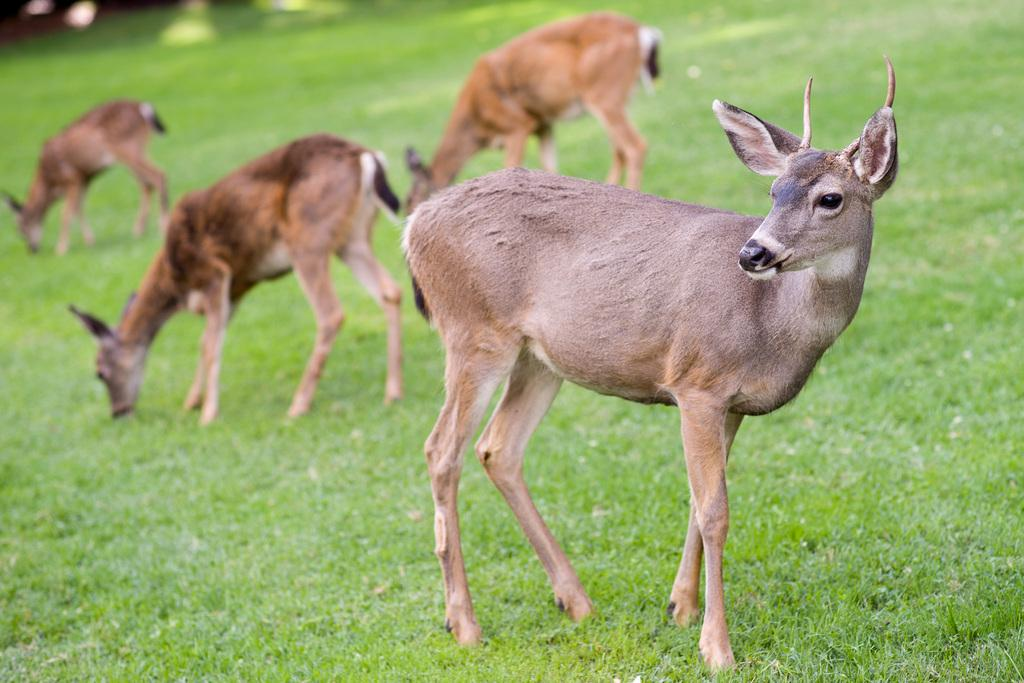What animal can be seen in the picture? There is a deer in the picture. What type of vegetation is present in the image? There is grass in the picture. Are there any dinosaurs flying a kite in the picture? No, there are no dinosaurs or kites present in the image. Is there a farmer tending to the deer in the picture? There is no farmer visible in the image, and the deer appears to be in its natural habitat. 